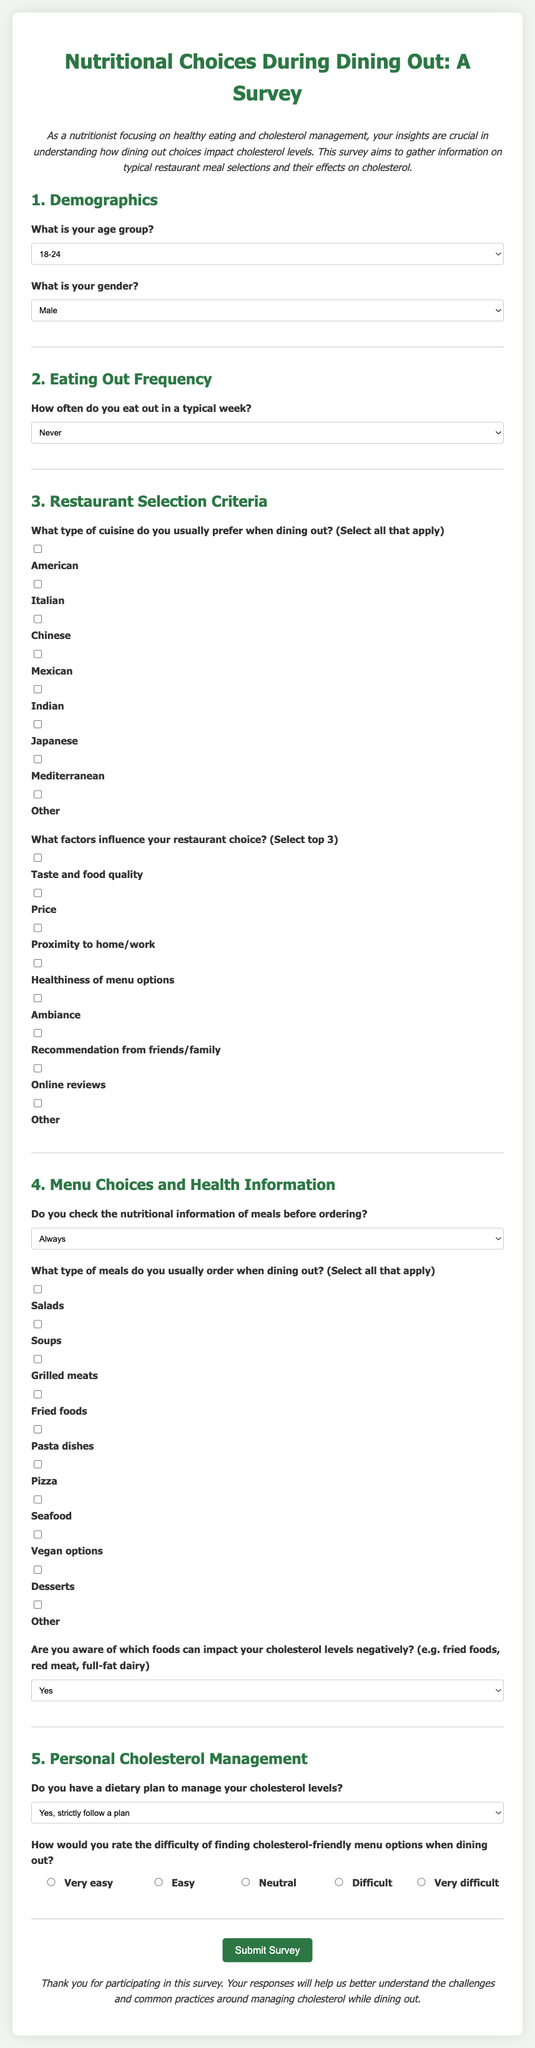What is the title of the survey? The title of the survey is displayed at the top of the document, making it easy to identify the subject.
Answer: Nutritional Choices During Dining Out: A Survey What is the first question in the demographics section? The first question in the demographics section asks about the age group of the participants.
Answer: What is your age group? How often do participants eat out in a typical week? The survey contains a question regarding the frequency of dining out, providing specific options for respondents.
Answer: How often do you eat out in a typical week? What factors should participants select that influence their restaurant choice? This question allows participants to choose the top three factors that influence their dining decisions, which includes various options like taste and healthiness.
Answer: What factors influence your restaurant choice? How would participants rate the difficulty of finding cholesterol-friendly menu options? The survey features a rating question that gauges the participants' perception of the ease or difficulty in finding suitable meal options.
Answer: How would you rate the difficulty of finding cholesterol-friendly menu options when dining out? What is the last question in the personal cholesterol management section? The last question in the personal cholesterol management section addresses how participants rate the difficulty of finding appropriate menu options.
Answer: How would you rate the difficulty of finding cholesterol-friendly menu options when dining out? 